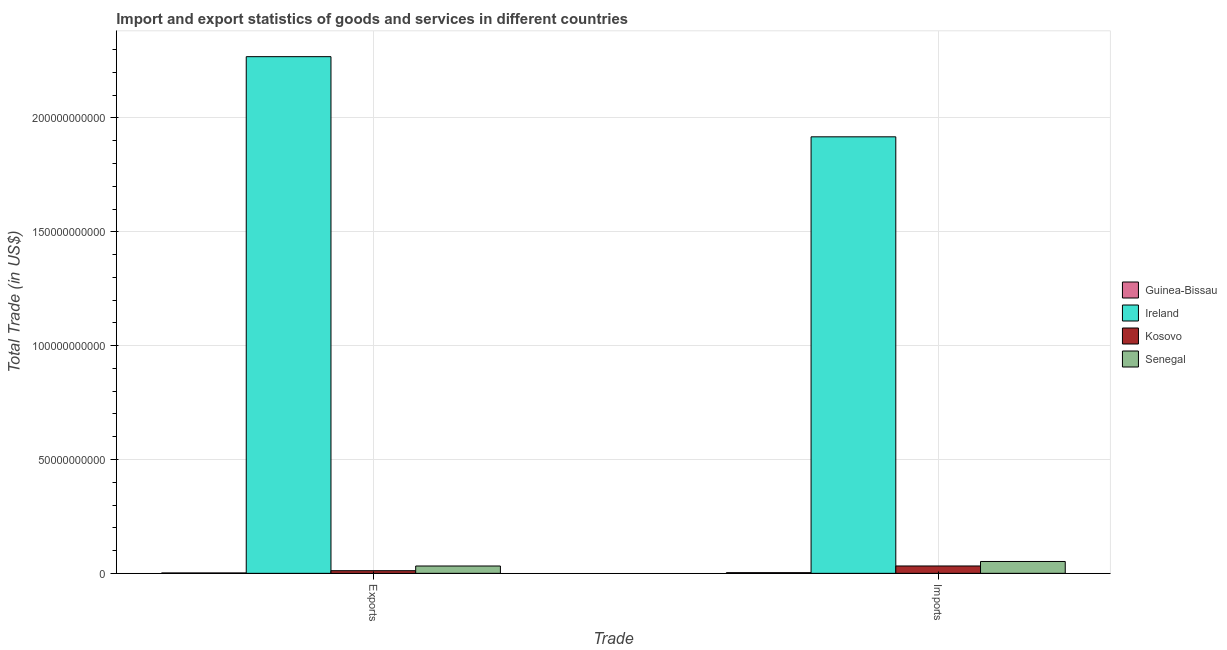How many different coloured bars are there?
Provide a succinct answer. 4. How many groups of bars are there?
Your answer should be compact. 2. How many bars are there on the 2nd tick from the right?
Your answer should be very brief. 4. What is the label of the 1st group of bars from the left?
Keep it short and to the point. Exports. What is the export of goods and services in Kosovo?
Offer a terse response. 1.16e+09. Across all countries, what is the maximum imports of goods and services?
Your answer should be very brief. 1.92e+11. Across all countries, what is the minimum export of goods and services?
Your response must be concise. 1.69e+08. In which country was the export of goods and services maximum?
Offer a very short reply. Ireland. In which country was the imports of goods and services minimum?
Offer a terse response. Guinea-Bissau. What is the total imports of goods and services in the graph?
Make the answer very short. 2.00e+11. What is the difference between the imports of goods and services in Ireland and that in Senegal?
Provide a short and direct response. 1.87e+11. What is the difference between the export of goods and services in Kosovo and the imports of goods and services in Guinea-Bissau?
Make the answer very short. 8.57e+08. What is the average export of goods and services per country?
Your response must be concise. 5.79e+1. What is the difference between the export of goods and services and imports of goods and services in Guinea-Bissau?
Ensure brevity in your answer.  -1.30e+08. What is the ratio of the imports of goods and services in Senegal to that in Guinea-Bissau?
Ensure brevity in your answer.  17.37. Is the export of goods and services in Kosovo less than that in Senegal?
Provide a succinct answer. Yes. What does the 1st bar from the left in Imports represents?
Give a very brief answer. Guinea-Bissau. What does the 3rd bar from the right in Imports represents?
Your answer should be very brief. Ireland. Are all the bars in the graph horizontal?
Make the answer very short. No. How many countries are there in the graph?
Keep it short and to the point. 4. What is the difference between two consecutive major ticks on the Y-axis?
Make the answer very short. 5.00e+1. Does the graph contain grids?
Ensure brevity in your answer.  Yes. Where does the legend appear in the graph?
Your answer should be very brief. Center right. What is the title of the graph?
Offer a terse response. Import and export statistics of goods and services in different countries. Does "OECD members" appear as one of the legend labels in the graph?
Provide a succinct answer. No. What is the label or title of the X-axis?
Offer a very short reply. Trade. What is the label or title of the Y-axis?
Keep it short and to the point. Total Trade (in US$). What is the Total Trade (in US$) of Guinea-Bissau in Exports?
Your answer should be very brief. 1.69e+08. What is the Total Trade (in US$) of Ireland in Exports?
Offer a very short reply. 2.27e+11. What is the Total Trade (in US$) of Kosovo in Exports?
Your response must be concise. 1.16e+09. What is the Total Trade (in US$) of Senegal in Exports?
Provide a succinct answer. 3.22e+09. What is the Total Trade (in US$) of Guinea-Bissau in Imports?
Keep it short and to the point. 3.00e+08. What is the Total Trade (in US$) of Ireland in Imports?
Your answer should be very brief. 1.92e+11. What is the Total Trade (in US$) in Kosovo in Imports?
Offer a very short reply. 3.23e+09. What is the Total Trade (in US$) of Senegal in Imports?
Ensure brevity in your answer.  5.20e+09. Across all Trade, what is the maximum Total Trade (in US$) of Guinea-Bissau?
Your response must be concise. 3.00e+08. Across all Trade, what is the maximum Total Trade (in US$) in Ireland?
Your answer should be very brief. 2.27e+11. Across all Trade, what is the maximum Total Trade (in US$) of Kosovo?
Give a very brief answer. 3.23e+09. Across all Trade, what is the maximum Total Trade (in US$) of Senegal?
Ensure brevity in your answer.  5.20e+09. Across all Trade, what is the minimum Total Trade (in US$) of Guinea-Bissau?
Your answer should be very brief. 1.69e+08. Across all Trade, what is the minimum Total Trade (in US$) in Ireland?
Your answer should be compact. 1.92e+11. Across all Trade, what is the minimum Total Trade (in US$) of Kosovo?
Your response must be concise. 1.16e+09. Across all Trade, what is the minimum Total Trade (in US$) of Senegal?
Your answer should be compact. 3.22e+09. What is the total Total Trade (in US$) in Guinea-Bissau in the graph?
Offer a very short reply. 4.69e+08. What is the total Total Trade (in US$) of Ireland in the graph?
Provide a succinct answer. 4.19e+11. What is the total Total Trade (in US$) in Kosovo in the graph?
Give a very brief answer. 4.39e+09. What is the total Total Trade (in US$) of Senegal in the graph?
Keep it short and to the point. 8.42e+09. What is the difference between the Total Trade (in US$) of Guinea-Bissau in Exports and that in Imports?
Make the answer very short. -1.30e+08. What is the difference between the Total Trade (in US$) in Ireland in Exports and that in Imports?
Your answer should be very brief. 3.52e+1. What is the difference between the Total Trade (in US$) of Kosovo in Exports and that in Imports?
Keep it short and to the point. -2.07e+09. What is the difference between the Total Trade (in US$) in Senegal in Exports and that in Imports?
Give a very brief answer. -1.99e+09. What is the difference between the Total Trade (in US$) in Guinea-Bissau in Exports and the Total Trade (in US$) in Ireland in Imports?
Offer a very short reply. -1.92e+11. What is the difference between the Total Trade (in US$) of Guinea-Bissau in Exports and the Total Trade (in US$) of Kosovo in Imports?
Ensure brevity in your answer.  -3.06e+09. What is the difference between the Total Trade (in US$) of Guinea-Bissau in Exports and the Total Trade (in US$) of Senegal in Imports?
Ensure brevity in your answer.  -5.04e+09. What is the difference between the Total Trade (in US$) in Ireland in Exports and the Total Trade (in US$) in Kosovo in Imports?
Your response must be concise. 2.24e+11. What is the difference between the Total Trade (in US$) in Ireland in Exports and the Total Trade (in US$) in Senegal in Imports?
Make the answer very short. 2.22e+11. What is the difference between the Total Trade (in US$) in Kosovo in Exports and the Total Trade (in US$) in Senegal in Imports?
Your response must be concise. -4.05e+09. What is the average Total Trade (in US$) in Guinea-Bissau per Trade?
Offer a terse response. 2.34e+08. What is the average Total Trade (in US$) of Ireland per Trade?
Give a very brief answer. 2.09e+11. What is the average Total Trade (in US$) of Kosovo per Trade?
Make the answer very short. 2.19e+09. What is the average Total Trade (in US$) of Senegal per Trade?
Keep it short and to the point. 4.21e+09. What is the difference between the Total Trade (in US$) of Guinea-Bissau and Total Trade (in US$) of Ireland in Exports?
Make the answer very short. -2.27e+11. What is the difference between the Total Trade (in US$) of Guinea-Bissau and Total Trade (in US$) of Kosovo in Exports?
Your answer should be very brief. -9.88e+08. What is the difference between the Total Trade (in US$) of Guinea-Bissau and Total Trade (in US$) of Senegal in Exports?
Offer a very short reply. -3.05e+09. What is the difference between the Total Trade (in US$) in Ireland and Total Trade (in US$) in Kosovo in Exports?
Your answer should be compact. 2.26e+11. What is the difference between the Total Trade (in US$) in Ireland and Total Trade (in US$) in Senegal in Exports?
Provide a short and direct response. 2.24e+11. What is the difference between the Total Trade (in US$) of Kosovo and Total Trade (in US$) of Senegal in Exports?
Provide a short and direct response. -2.06e+09. What is the difference between the Total Trade (in US$) in Guinea-Bissau and Total Trade (in US$) in Ireland in Imports?
Provide a short and direct response. -1.91e+11. What is the difference between the Total Trade (in US$) in Guinea-Bissau and Total Trade (in US$) in Kosovo in Imports?
Keep it short and to the point. -2.93e+09. What is the difference between the Total Trade (in US$) in Guinea-Bissau and Total Trade (in US$) in Senegal in Imports?
Offer a very short reply. -4.91e+09. What is the difference between the Total Trade (in US$) of Ireland and Total Trade (in US$) of Kosovo in Imports?
Your response must be concise. 1.88e+11. What is the difference between the Total Trade (in US$) of Ireland and Total Trade (in US$) of Senegal in Imports?
Your response must be concise. 1.87e+11. What is the difference between the Total Trade (in US$) in Kosovo and Total Trade (in US$) in Senegal in Imports?
Make the answer very short. -1.97e+09. What is the ratio of the Total Trade (in US$) of Guinea-Bissau in Exports to that in Imports?
Make the answer very short. 0.57. What is the ratio of the Total Trade (in US$) of Ireland in Exports to that in Imports?
Give a very brief answer. 1.18. What is the ratio of the Total Trade (in US$) of Kosovo in Exports to that in Imports?
Your answer should be compact. 0.36. What is the ratio of the Total Trade (in US$) in Senegal in Exports to that in Imports?
Your answer should be very brief. 0.62. What is the difference between the highest and the second highest Total Trade (in US$) of Guinea-Bissau?
Offer a terse response. 1.30e+08. What is the difference between the highest and the second highest Total Trade (in US$) of Ireland?
Offer a terse response. 3.52e+1. What is the difference between the highest and the second highest Total Trade (in US$) of Kosovo?
Offer a very short reply. 2.07e+09. What is the difference between the highest and the second highest Total Trade (in US$) of Senegal?
Provide a short and direct response. 1.99e+09. What is the difference between the highest and the lowest Total Trade (in US$) in Guinea-Bissau?
Make the answer very short. 1.30e+08. What is the difference between the highest and the lowest Total Trade (in US$) in Ireland?
Offer a very short reply. 3.52e+1. What is the difference between the highest and the lowest Total Trade (in US$) of Kosovo?
Provide a succinct answer. 2.07e+09. What is the difference between the highest and the lowest Total Trade (in US$) of Senegal?
Make the answer very short. 1.99e+09. 